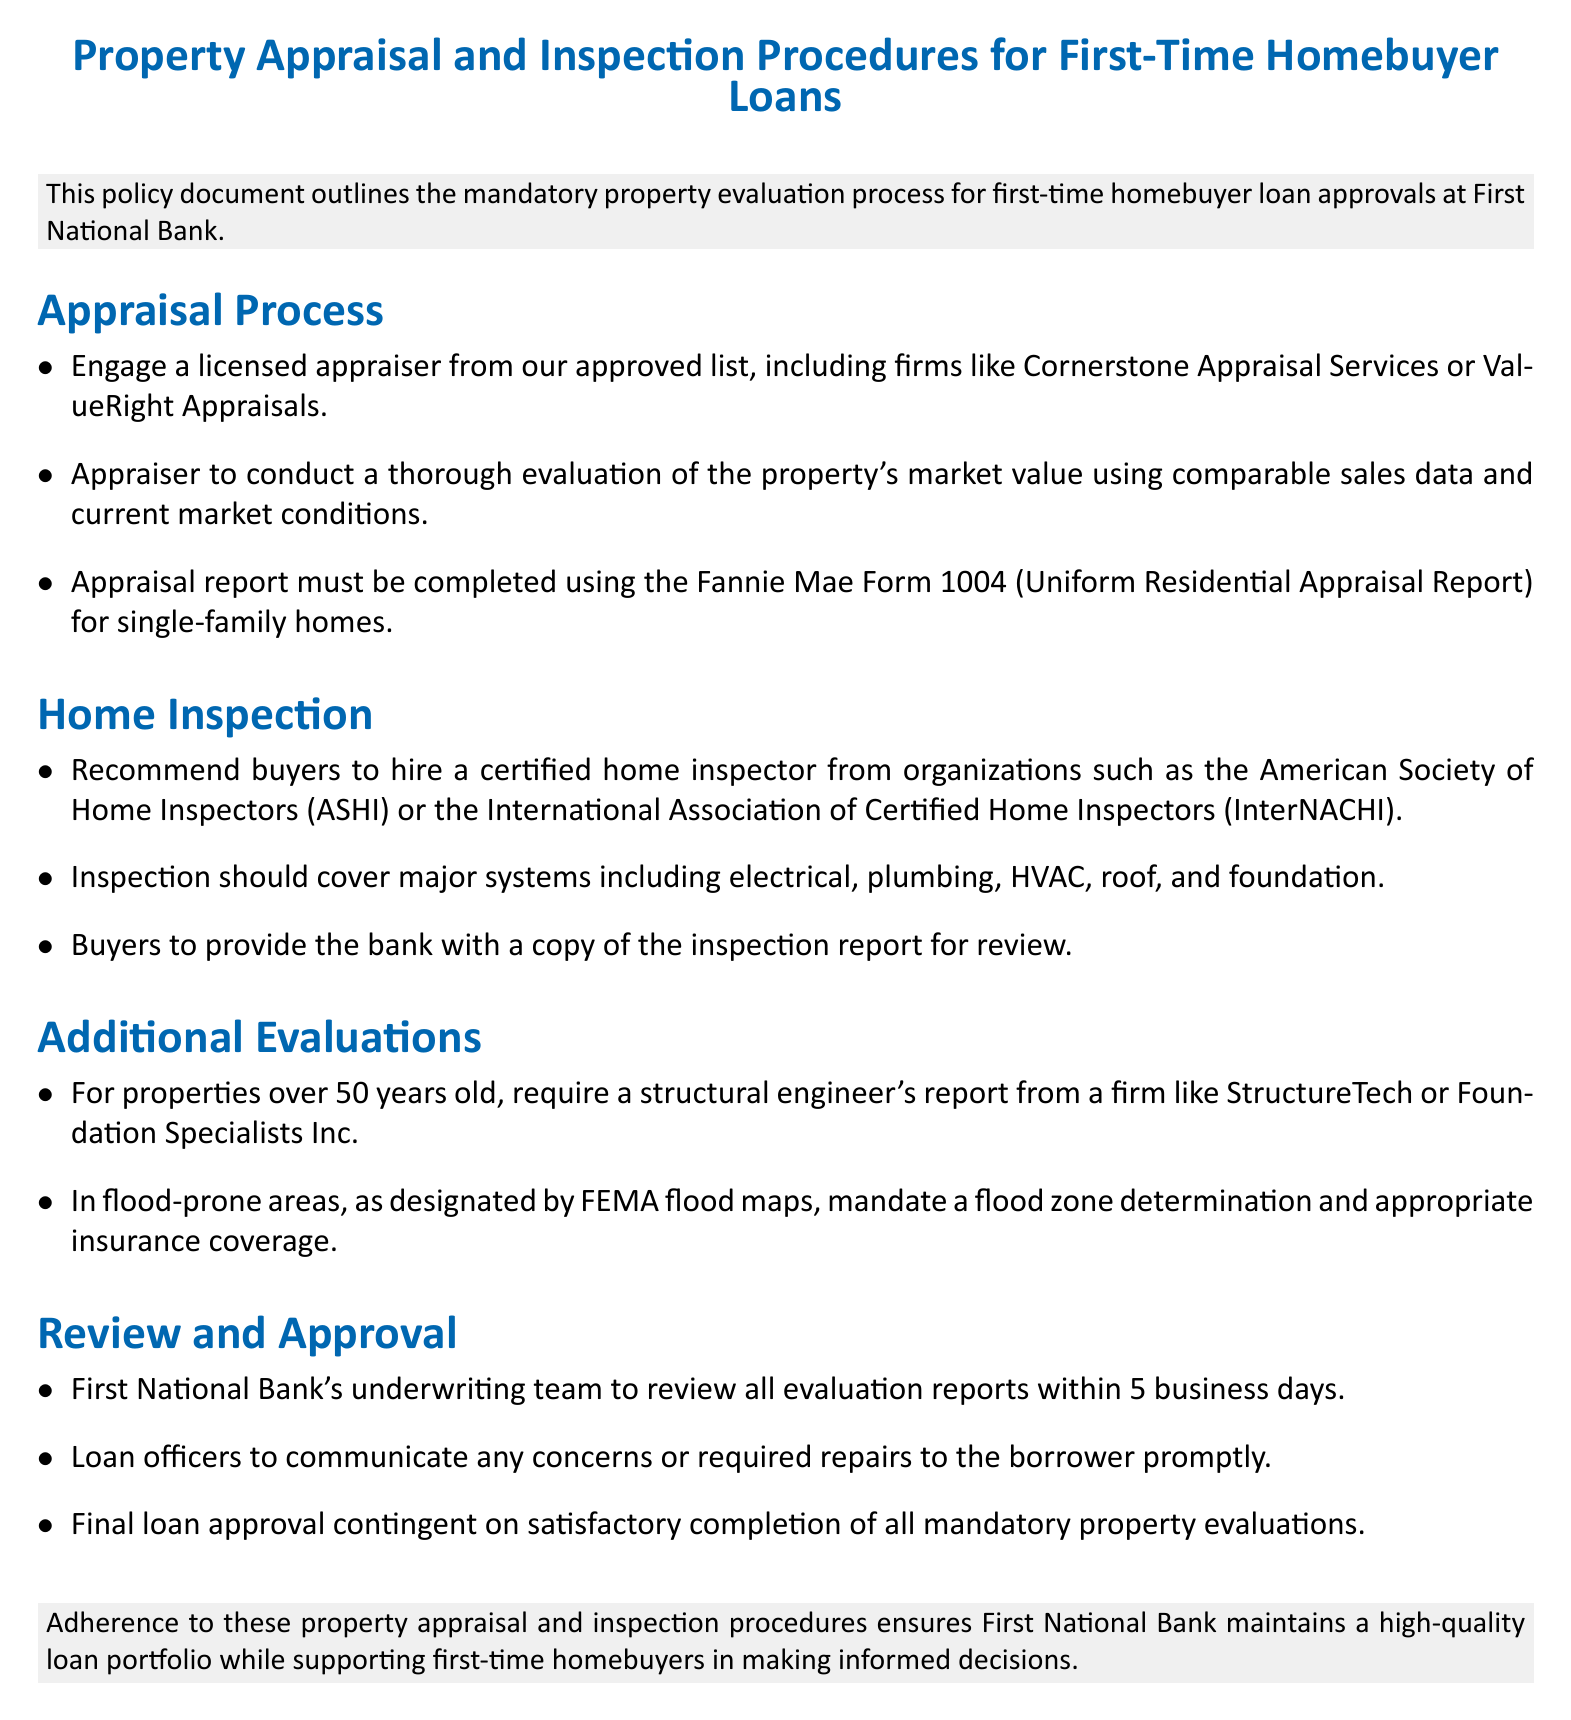What is the title of the document? The title indicates the main subject of the document, which is the procedures for appraisals and inspections for first-time homebuyer loans.
Answer: Property Appraisal and Inspection Procedures for First-Time Homebuyer Loans Which firms are mentioned for the appraisal process? The document lists approved firms for appraisals to highlight their credibility and selection for the process.
Answer: Cornerstone Appraisal Services, ValueRight Appraisals What form must the appraisal report be completed with? The specified form indicates the standardized documentation required for appraisal reporting in this context.
Answer: Fannie Mae Form 1004 Who should buyers hire for the home inspection? This question addresses the recommendations made to ensure quality home inspections by certified professionals, benefiting the buyers.
Answer: Certified home inspector What major systems should be inspected? The question identifies the key areas to be evaluated during a home inspection, essential for the buyer's decision-making.
Answer: Electrical, plumbing, HVAC, roof, and foundation What is required for properties over 50 years old? This question points to additional requirements in the case of older properties, indicating their unique evaluation needs.
Answer: Structural engineer's report How long does the underwriting team take to review evaluation reports? This duration informs about the efficiency and timeline of the loan approval process, crucial for borrowers’ expectations.
Answer: 5 business days What does the final loan approval depend on? Understanding the conditions of loan approval at First National Bank helps inform borrowers about the obligations tied to their application.
Answer: Satisfactory completion of all mandatory property evaluations 